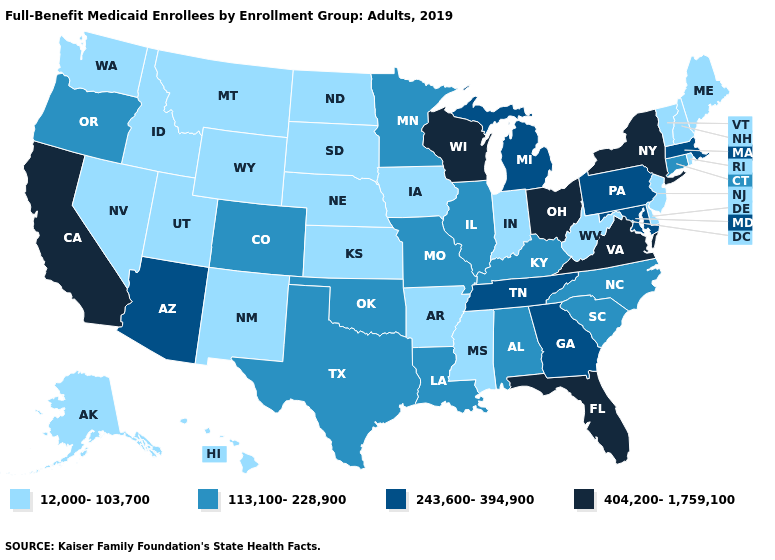Among the states that border North Dakota , does South Dakota have the highest value?
Concise answer only. No. What is the value of Kentucky?
Give a very brief answer. 113,100-228,900. Among the states that border Utah , which have the highest value?
Short answer required. Arizona. What is the value of Pennsylvania?
Concise answer only. 243,600-394,900. What is the value of Delaware?
Short answer required. 12,000-103,700. What is the value of Colorado?
Answer briefly. 113,100-228,900. Which states have the lowest value in the USA?
Be succinct. Alaska, Arkansas, Delaware, Hawaii, Idaho, Indiana, Iowa, Kansas, Maine, Mississippi, Montana, Nebraska, Nevada, New Hampshire, New Jersey, New Mexico, North Dakota, Rhode Island, South Dakota, Utah, Vermont, Washington, West Virginia, Wyoming. What is the value of Virginia?
Quick response, please. 404,200-1,759,100. Name the states that have a value in the range 113,100-228,900?
Short answer required. Alabama, Colorado, Connecticut, Illinois, Kentucky, Louisiana, Minnesota, Missouri, North Carolina, Oklahoma, Oregon, South Carolina, Texas. What is the value of Mississippi?
Short answer required. 12,000-103,700. Among the states that border Illinois , which have the highest value?
Give a very brief answer. Wisconsin. Is the legend a continuous bar?
Keep it brief. No. What is the lowest value in the Northeast?
Answer briefly. 12,000-103,700. Does Rhode Island have a lower value than Florida?
Short answer required. Yes. Which states have the lowest value in the South?
Short answer required. Arkansas, Delaware, Mississippi, West Virginia. 